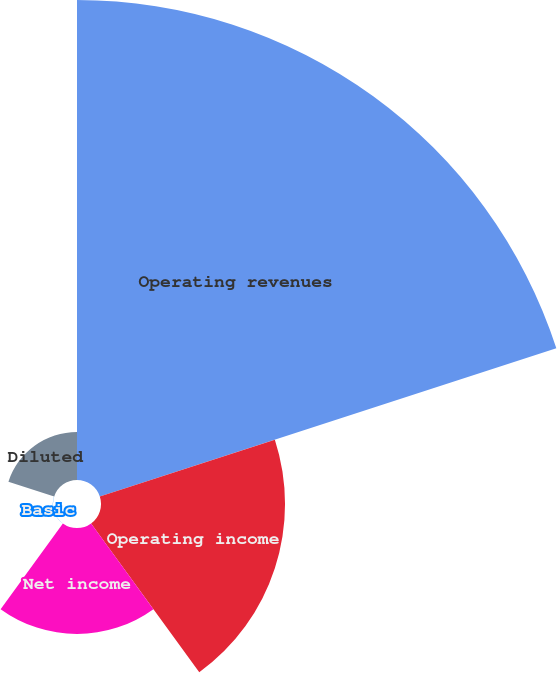<chart> <loc_0><loc_0><loc_500><loc_500><pie_chart><fcel>Operating revenues<fcel>Operating income<fcel>Net income<fcel>Basic<fcel>Diluted<nl><fcel>58.66%<fcel>22.49%<fcel>12.95%<fcel>0.02%<fcel>5.88%<nl></chart> 